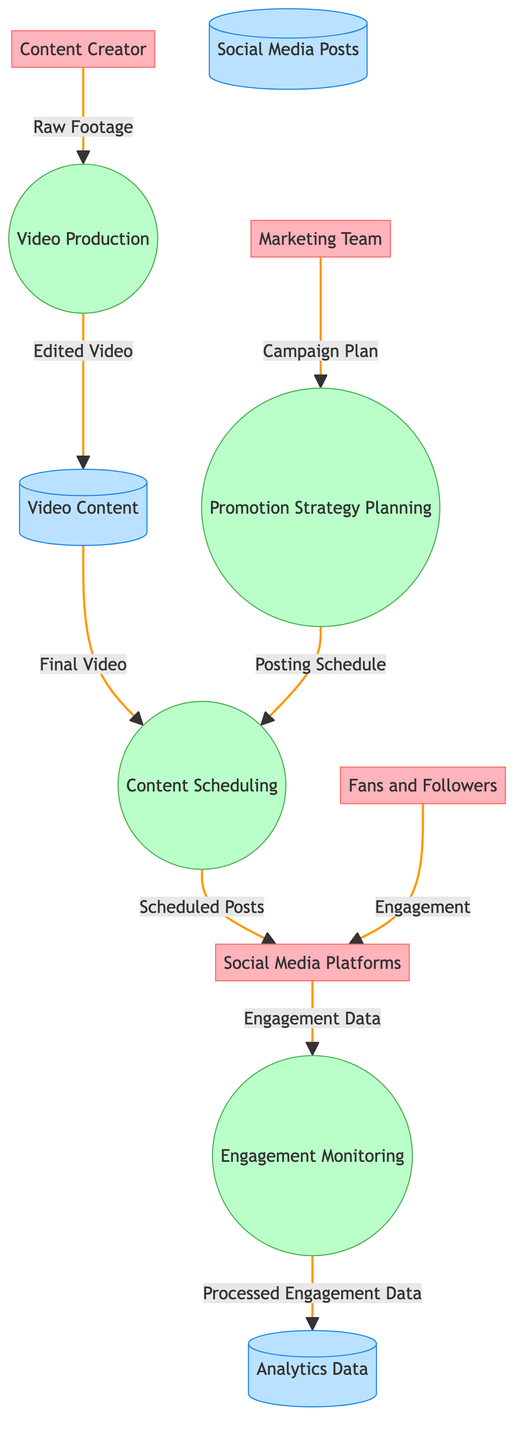What is the first process in the diagram? The first process that receives input from the Content Creator, marked by an arrow pointing from the Content Creator to the Video Production, is Video Production.
Answer: Video Production How many entities are there in the diagram? By counting the distinct entities listed in the diagram, we find four: Content Creator, Social Media Platforms, Fans and Followers, and Marketing Team, totaling to four entities.
Answer: Four What data flows from Video Production to Video Content? According to the diagram, the flow from Video Production to Video Content is represented by the data labeled as Edited Video.
Answer: Edited Video Which process is responsible for tracking audience interactions? The process that deals with monitoring audience interactions and feedback from the Social Media Platforms is named Engagement Monitoring.
Answer: Engagement Monitoring How many data stores are present in the diagram? The diagram includes three distinct data stores, which are Video Content, Social Media Posts, and Analytics Data.
Answer: Three What follows after the Marketing Team sends the Campaign Plan? The Campaign Plan sent from the Marketing Team leads to the next process known as Promotion Strategy Planning, as indicated by the flow from Marketing Team to Promotion Strategy Planning.
Answer: Promotion Strategy Planning What is the last data flow in the diagram? The last data flow shown in the diagram goes from Engagement Monitoring to Analytics Data, carrying the labeled data Processed Engagement Data.
Answer: Processed Engagement Data What type of engagement do fans provide to social media platforms? The data coming from Fans and Followers to Social Media Platforms is categorized as Engagement.
Answer: Engagement Which two processes directly interact with the Social Media Platforms? The two processes interacting directly with Social Media Platforms are Content Scheduling and Engagement Monitoring, described by their respective arrows pointing to and from the Social Media Platforms.
Answer: Content Scheduling and Engagement Monitoring 